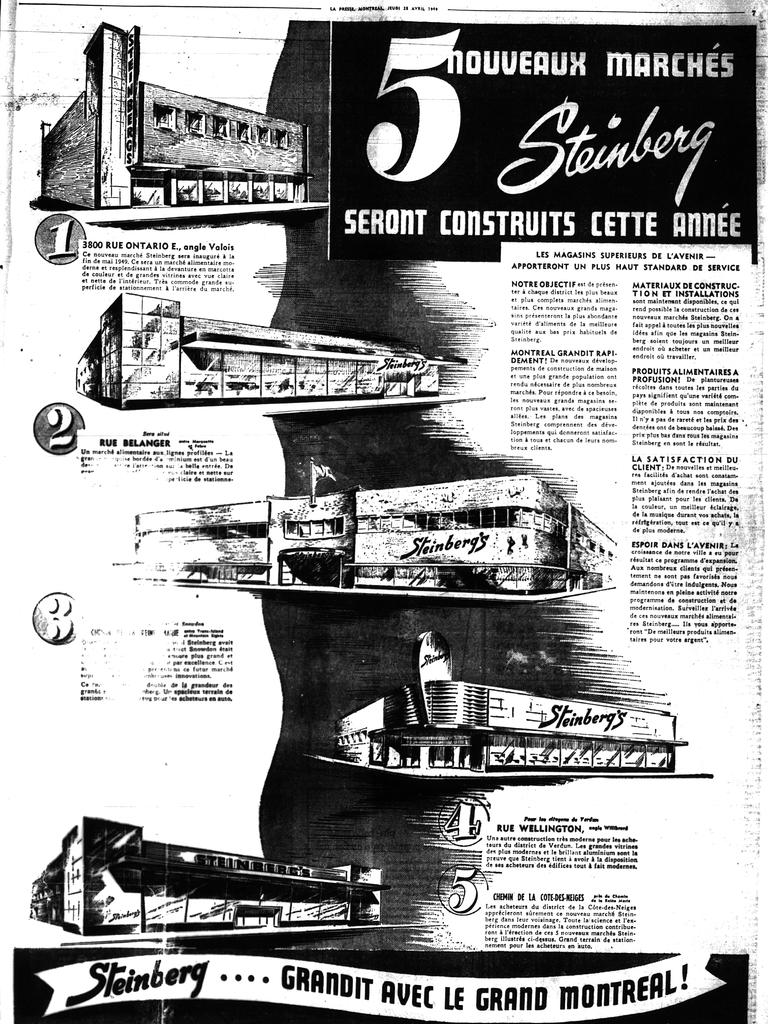Provide a one-sentence caption for the provided image. Page from a black and white publication with the title 5nouveaux marches Steinberg at the top. 